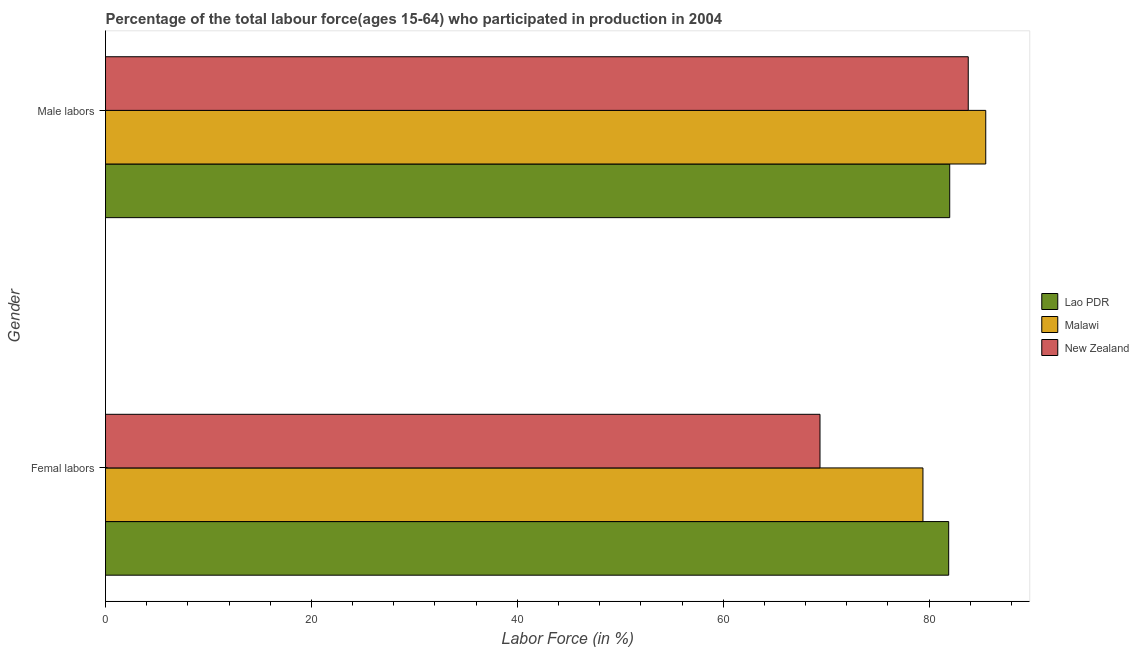How many different coloured bars are there?
Give a very brief answer. 3. Are the number of bars per tick equal to the number of legend labels?
Ensure brevity in your answer.  Yes. Are the number of bars on each tick of the Y-axis equal?
Keep it short and to the point. Yes. How many bars are there on the 2nd tick from the top?
Provide a succinct answer. 3. What is the label of the 1st group of bars from the top?
Your response must be concise. Male labors. Across all countries, what is the maximum percentage of male labour force?
Give a very brief answer. 85.5. Across all countries, what is the minimum percentage of female labor force?
Your answer should be very brief. 69.4. In which country was the percentage of female labor force maximum?
Give a very brief answer. Lao PDR. In which country was the percentage of male labour force minimum?
Provide a succinct answer. Lao PDR. What is the total percentage of female labor force in the graph?
Give a very brief answer. 230.7. What is the difference between the percentage of female labor force in New Zealand and that in Malawi?
Your answer should be very brief. -10. What is the difference between the percentage of female labor force in Malawi and the percentage of male labour force in New Zealand?
Provide a short and direct response. -4.4. What is the average percentage of male labour force per country?
Offer a terse response. 83.77. What is the difference between the percentage of male labour force and percentage of female labor force in Malawi?
Offer a very short reply. 6.1. What is the ratio of the percentage of male labour force in New Zealand to that in Malawi?
Your answer should be very brief. 0.98. Is the percentage of female labor force in Malawi less than that in New Zealand?
Keep it short and to the point. No. In how many countries, is the percentage of female labor force greater than the average percentage of female labor force taken over all countries?
Offer a very short reply. 2. What does the 3rd bar from the top in Male labors represents?
Offer a terse response. Lao PDR. What does the 1st bar from the bottom in Male labors represents?
Your answer should be very brief. Lao PDR. How many bars are there?
Your response must be concise. 6. How many countries are there in the graph?
Offer a very short reply. 3. Does the graph contain grids?
Ensure brevity in your answer.  No. Where does the legend appear in the graph?
Give a very brief answer. Center right. What is the title of the graph?
Offer a terse response. Percentage of the total labour force(ages 15-64) who participated in production in 2004. Does "Belize" appear as one of the legend labels in the graph?
Your answer should be compact. No. What is the label or title of the X-axis?
Your response must be concise. Labor Force (in %). What is the Labor Force (in %) of Lao PDR in Femal labors?
Offer a very short reply. 81.9. What is the Labor Force (in %) in Malawi in Femal labors?
Your answer should be compact. 79.4. What is the Labor Force (in %) in New Zealand in Femal labors?
Give a very brief answer. 69.4. What is the Labor Force (in %) of Malawi in Male labors?
Ensure brevity in your answer.  85.5. What is the Labor Force (in %) in New Zealand in Male labors?
Offer a very short reply. 83.8. Across all Gender, what is the maximum Labor Force (in %) in Lao PDR?
Provide a short and direct response. 82. Across all Gender, what is the maximum Labor Force (in %) of Malawi?
Make the answer very short. 85.5. Across all Gender, what is the maximum Labor Force (in %) in New Zealand?
Give a very brief answer. 83.8. Across all Gender, what is the minimum Labor Force (in %) in Lao PDR?
Keep it short and to the point. 81.9. Across all Gender, what is the minimum Labor Force (in %) in Malawi?
Make the answer very short. 79.4. Across all Gender, what is the minimum Labor Force (in %) in New Zealand?
Offer a very short reply. 69.4. What is the total Labor Force (in %) of Lao PDR in the graph?
Your answer should be very brief. 163.9. What is the total Labor Force (in %) of Malawi in the graph?
Provide a succinct answer. 164.9. What is the total Labor Force (in %) in New Zealand in the graph?
Your answer should be compact. 153.2. What is the difference between the Labor Force (in %) in New Zealand in Femal labors and that in Male labors?
Offer a terse response. -14.4. What is the difference between the Labor Force (in %) of Lao PDR in Femal labors and the Labor Force (in %) of New Zealand in Male labors?
Give a very brief answer. -1.9. What is the average Labor Force (in %) in Lao PDR per Gender?
Your answer should be very brief. 81.95. What is the average Labor Force (in %) of Malawi per Gender?
Offer a terse response. 82.45. What is the average Labor Force (in %) of New Zealand per Gender?
Provide a succinct answer. 76.6. What is the difference between the Labor Force (in %) of Lao PDR and Labor Force (in %) of New Zealand in Femal labors?
Keep it short and to the point. 12.5. What is the difference between the Labor Force (in %) of Lao PDR and Labor Force (in %) of Malawi in Male labors?
Provide a short and direct response. -3.5. What is the difference between the Labor Force (in %) of Lao PDR and Labor Force (in %) of New Zealand in Male labors?
Your answer should be compact. -1.8. What is the difference between the Labor Force (in %) in Malawi and Labor Force (in %) in New Zealand in Male labors?
Offer a very short reply. 1.7. What is the ratio of the Labor Force (in %) of Malawi in Femal labors to that in Male labors?
Your response must be concise. 0.93. What is the ratio of the Labor Force (in %) of New Zealand in Femal labors to that in Male labors?
Provide a succinct answer. 0.83. What is the difference between the highest and the second highest Labor Force (in %) of Malawi?
Your answer should be compact. 6.1. What is the difference between the highest and the lowest Labor Force (in %) in Lao PDR?
Provide a succinct answer. 0.1. What is the difference between the highest and the lowest Labor Force (in %) of Malawi?
Your answer should be compact. 6.1. What is the difference between the highest and the lowest Labor Force (in %) of New Zealand?
Provide a short and direct response. 14.4. 